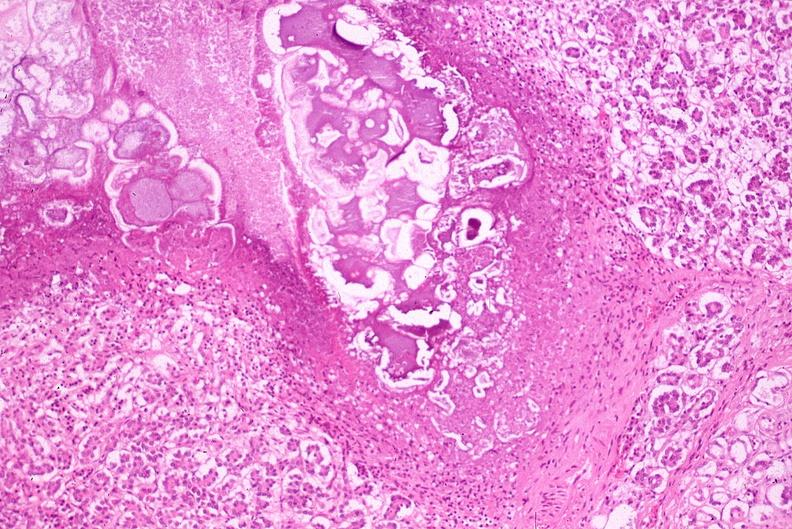where is this?
Answer the question using a single word or phrase. Pancreas 